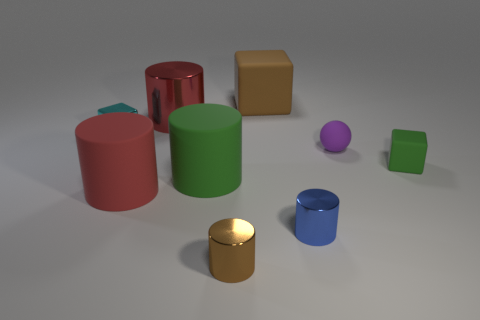Subtract all tiny blue cylinders. How many cylinders are left? 4 Subtract 3 cylinders. How many cylinders are left? 2 Subtract all green cylinders. How many cylinders are left? 4 Add 1 tiny green things. How many objects exist? 10 Subtract all brown cylinders. Subtract all yellow spheres. How many cylinders are left? 4 Subtract all cylinders. How many objects are left? 4 Subtract 1 purple spheres. How many objects are left? 8 Subtract all big green rubber cylinders. Subtract all tiny cubes. How many objects are left? 6 Add 6 purple rubber spheres. How many purple rubber spheres are left? 7 Add 7 large red metal things. How many large red metal things exist? 8 